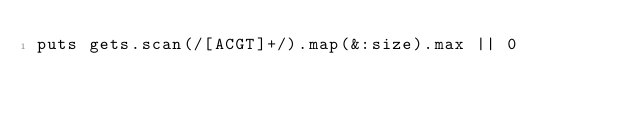<code> <loc_0><loc_0><loc_500><loc_500><_Ruby_>puts gets.scan(/[ACGT]+/).map(&:size).max || 0</code> 